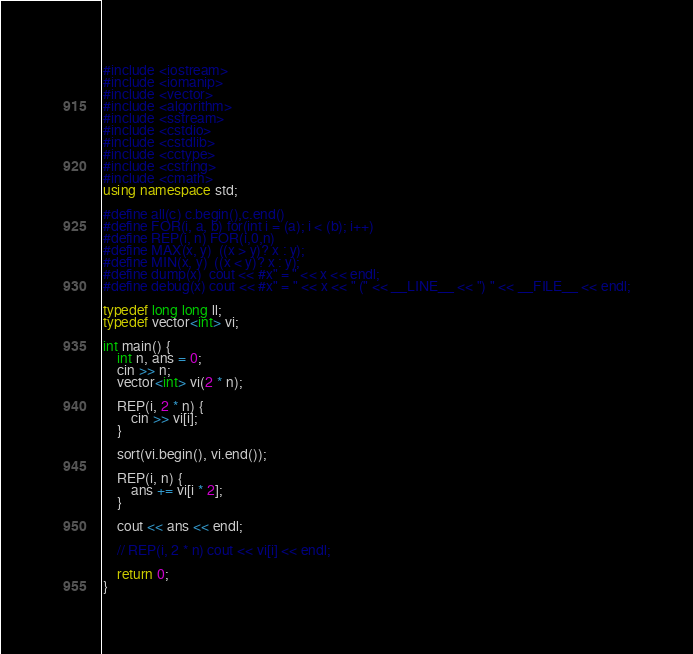<code> <loc_0><loc_0><loc_500><loc_500><_C++_>#include <iostream>
#include <iomanip>
#include <vector>
#include <algorithm>
#include <sstream>
#include <cstdio>
#include <cstdlib>
#include <cctype>
#include <cstring>
#include <cmath>
using namespace std;

#define all(c) c.begin(),c.end()
#define FOR(i, a, b) for(int i = (a); i < (b); i++)
#define REP(i, n) FOR(i,0,n)
#define MAX(x, y)  ((x > y)? x : y);
#define MIN(x, y)  ((x < y)? x : y);
#define dump(x)  cout << #x" = " << x << endl;
#define debug(x) cout << #x" = " << x << " (" << __LINE__ << ") " << __FILE__ << endl;

typedef long long ll;
typedef vector<int> vi;

int main() {
	int n, ans = 0;
	cin >> n;
	vector<int> vi(2 * n);

	REP(i, 2 * n) {
		cin >> vi[i];
	}

	sort(vi.begin(), vi.end());

	REP(i, n) {
		ans += vi[i * 2];
	}

	cout << ans << endl;

	// REP(i, 2 * n) cout << vi[i] << endl;

	return 0;
}</code> 